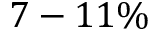Convert formula to latex. <formula><loc_0><loc_0><loc_500><loc_500>7 - 1 1 \%</formula> 